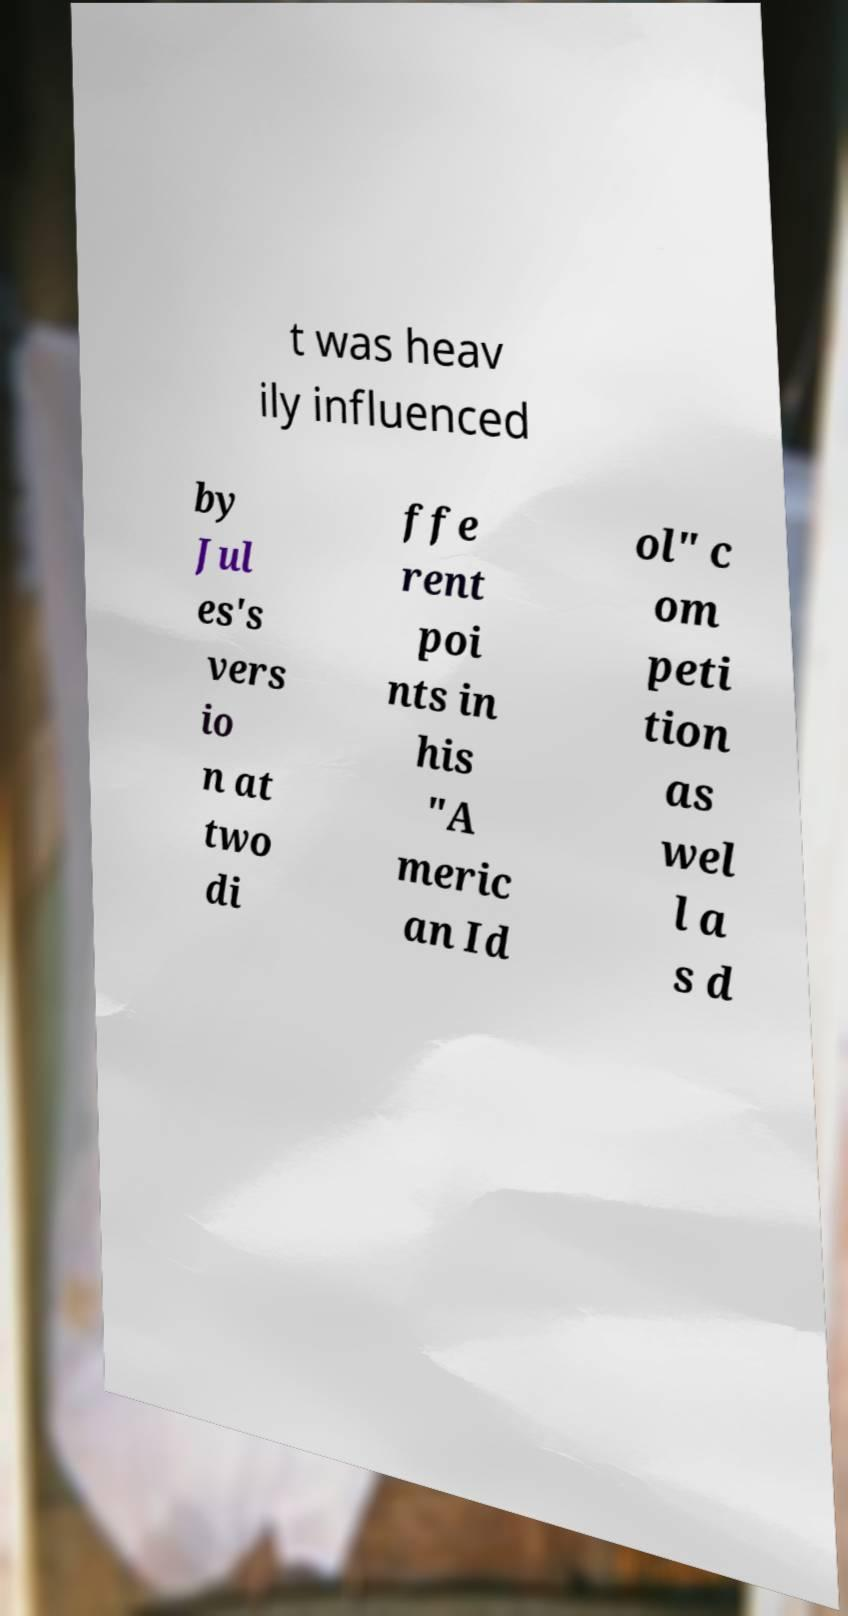I need the written content from this picture converted into text. Can you do that? t was heav ily influenced by Jul es's vers io n at two di ffe rent poi nts in his "A meric an Id ol" c om peti tion as wel l a s d 